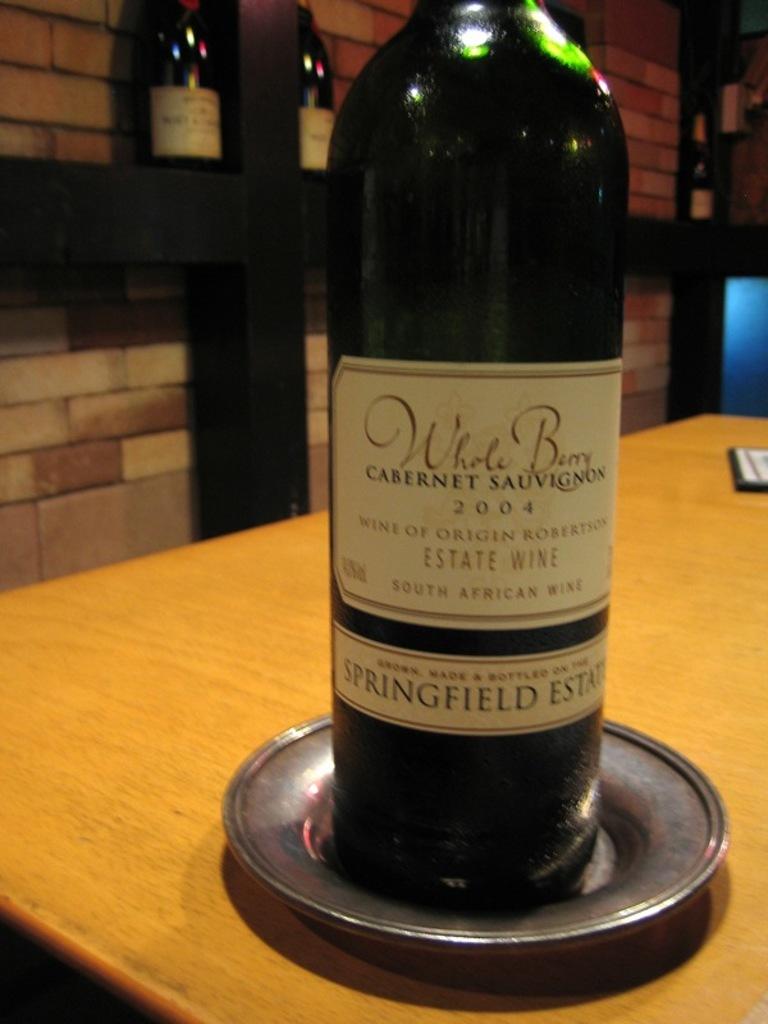What brand is the green bottle?
Make the answer very short. Whole berry. 